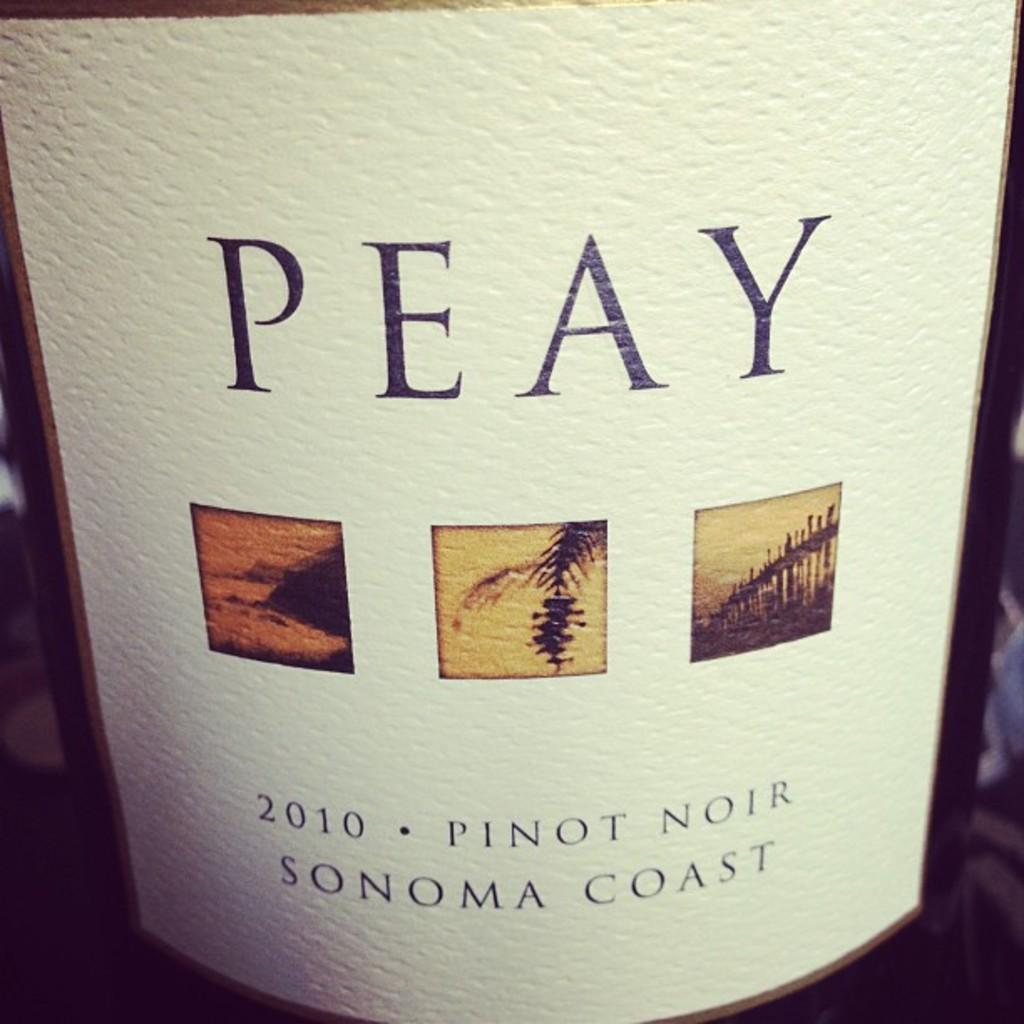Provide a one-sentence caption for the provided image. A bottle of wine that was made in 2010. 